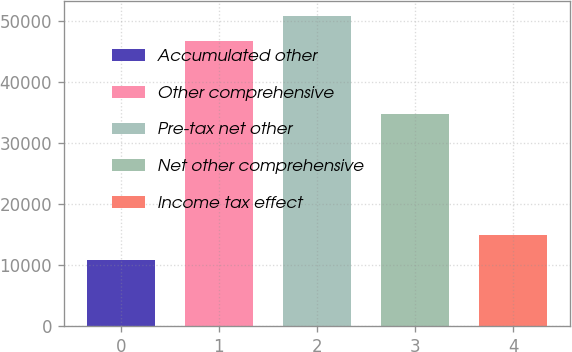Convert chart to OTSL. <chart><loc_0><loc_0><loc_500><loc_500><bar_chart><fcel>Accumulated other<fcel>Other comprehensive<fcel>Pre-tax net other<fcel>Net other comprehensive<fcel>Income tax effect<nl><fcel>10807.8<fcel>46680<fcel>50738.8<fcel>34806<fcel>14866.6<nl></chart> 